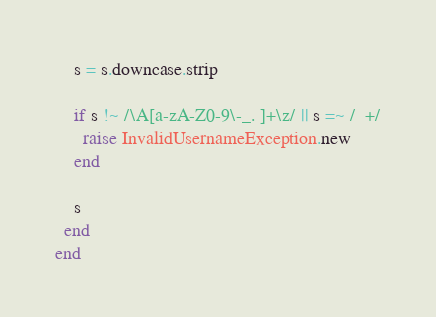Convert code to text. <code><loc_0><loc_0><loc_500><loc_500><_Ruby_>    s = s.downcase.strip

    if s !~ /\A[a-zA-Z0-9\-_. ]+\z/ || s =~ /  +/
      raise InvalidUsernameException.new
    end

    s
  end
end
</code> 